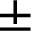Convert formula to latex. <formula><loc_0><loc_0><loc_500><loc_500>\pm</formula> 